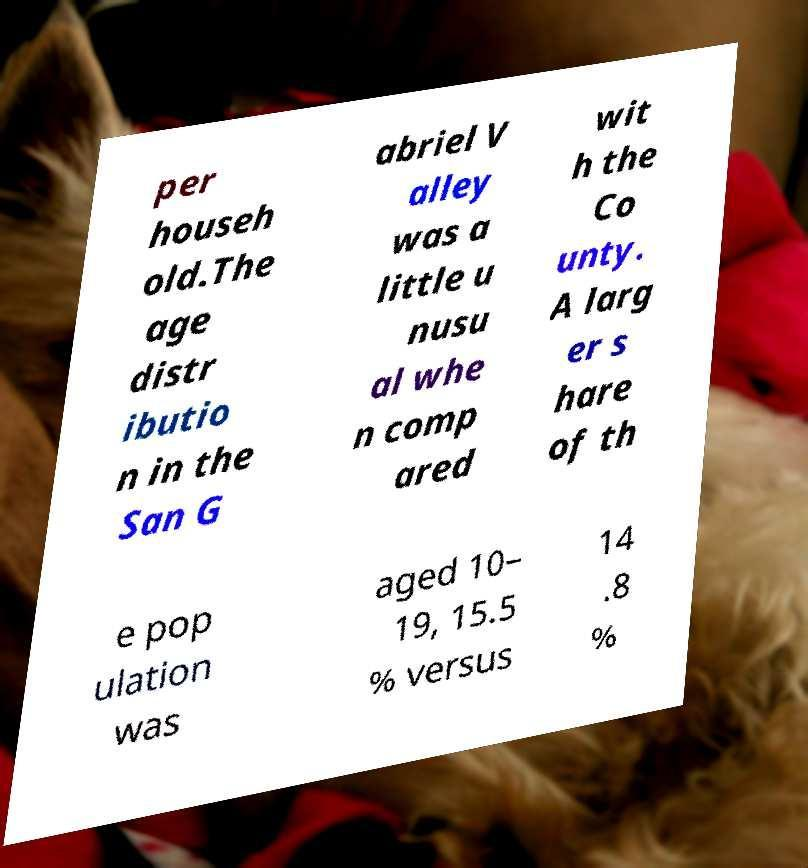I need the written content from this picture converted into text. Can you do that? per househ old.The age distr ibutio n in the San G abriel V alley was a little u nusu al whe n comp ared wit h the Co unty. A larg er s hare of th e pop ulation was aged 10– 19, 15.5 % versus 14 .8 % 